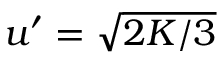Convert formula to latex. <formula><loc_0><loc_0><loc_500><loc_500>u ^ { \prime } = \sqrt { 2 K / 3 }</formula> 